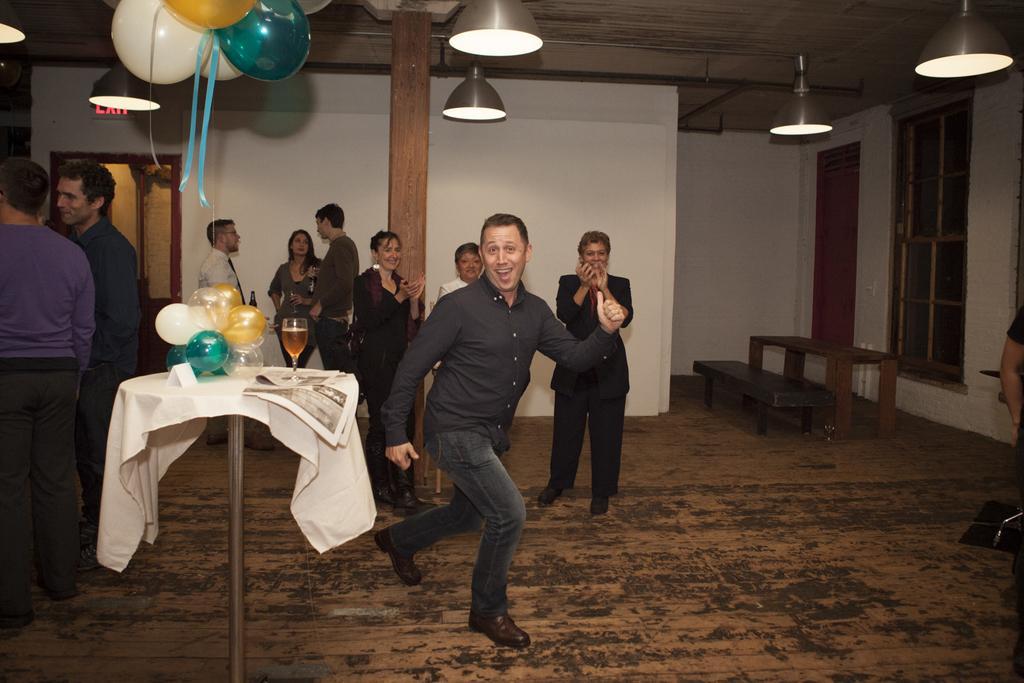Could you give a brief overview of what you see in this image? In this picture there is a man who is standing near to the table. On the table I can see the balloons, papers, wine glasses and white cloth. In the back I can see some people were standing near to the pillar and they are smiling. Beside them I can see another group of persons were standing near to the projector screen. At the top I can see the balloon, lights. On the right I can see the table, bench and window. On the left I can see two men were standing near to the door. 